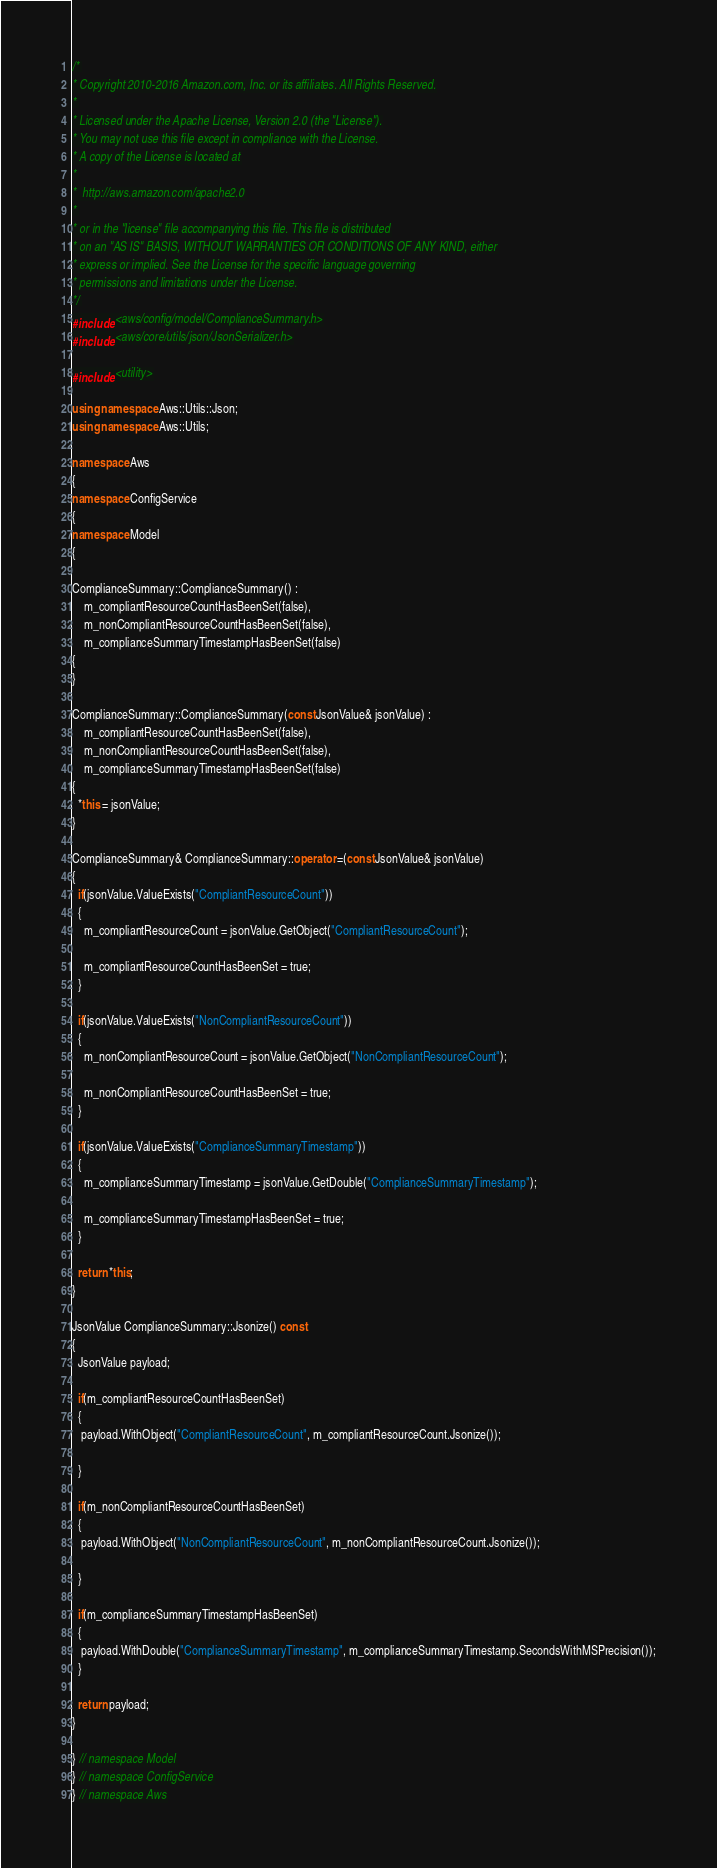Convert code to text. <code><loc_0><loc_0><loc_500><loc_500><_C++_>/*
* Copyright 2010-2016 Amazon.com, Inc. or its affiliates. All Rights Reserved.
*
* Licensed under the Apache License, Version 2.0 (the "License").
* You may not use this file except in compliance with the License.
* A copy of the License is located at
*
*  http://aws.amazon.com/apache2.0
*
* or in the "license" file accompanying this file. This file is distributed
* on an "AS IS" BASIS, WITHOUT WARRANTIES OR CONDITIONS OF ANY KIND, either
* express or implied. See the License for the specific language governing
* permissions and limitations under the License.
*/
#include <aws/config/model/ComplianceSummary.h>
#include <aws/core/utils/json/JsonSerializer.h>

#include <utility>

using namespace Aws::Utils::Json;
using namespace Aws::Utils;

namespace Aws
{
namespace ConfigService
{
namespace Model
{

ComplianceSummary::ComplianceSummary() : 
    m_compliantResourceCountHasBeenSet(false),
    m_nonCompliantResourceCountHasBeenSet(false),
    m_complianceSummaryTimestampHasBeenSet(false)
{
}

ComplianceSummary::ComplianceSummary(const JsonValue& jsonValue) : 
    m_compliantResourceCountHasBeenSet(false),
    m_nonCompliantResourceCountHasBeenSet(false),
    m_complianceSummaryTimestampHasBeenSet(false)
{
  *this = jsonValue;
}

ComplianceSummary& ComplianceSummary::operator =(const JsonValue& jsonValue)
{
  if(jsonValue.ValueExists("CompliantResourceCount"))
  {
    m_compliantResourceCount = jsonValue.GetObject("CompliantResourceCount");

    m_compliantResourceCountHasBeenSet = true;
  }

  if(jsonValue.ValueExists("NonCompliantResourceCount"))
  {
    m_nonCompliantResourceCount = jsonValue.GetObject("NonCompliantResourceCount");

    m_nonCompliantResourceCountHasBeenSet = true;
  }

  if(jsonValue.ValueExists("ComplianceSummaryTimestamp"))
  {
    m_complianceSummaryTimestamp = jsonValue.GetDouble("ComplianceSummaryTimestamp");

    m_complianceSummaryTimestampHasBeenSet = true;
  }

  return *this;
}

JsonValue ComplianceSummary::Jsonize() const
{
  JsonValue payload;

  if(m_compliantResourceCountHasBeenSet)
  {
   payload.WithObject("CompliantResourceCount", m_compliantResourceCount.Jsonize());

  }

  if(m_nonCompliantResourceCountHasBeenSet)
  {
   payload.WithObject("NonCompliantResourceCount", m_nonCompliantResourceCount.Jsonize());

  }

  if(m_complianceSummaryTimestampHasBeenSet)
  {
   payload.WithDouble("ComplianceSummaryTimestamp", m_complianceSummaryTimestamp.SecondsWithMSPrecision());
  }

  return payload;
}

} // namespace Model
} // namespace ConfigService
} // namespace Aws</code> 